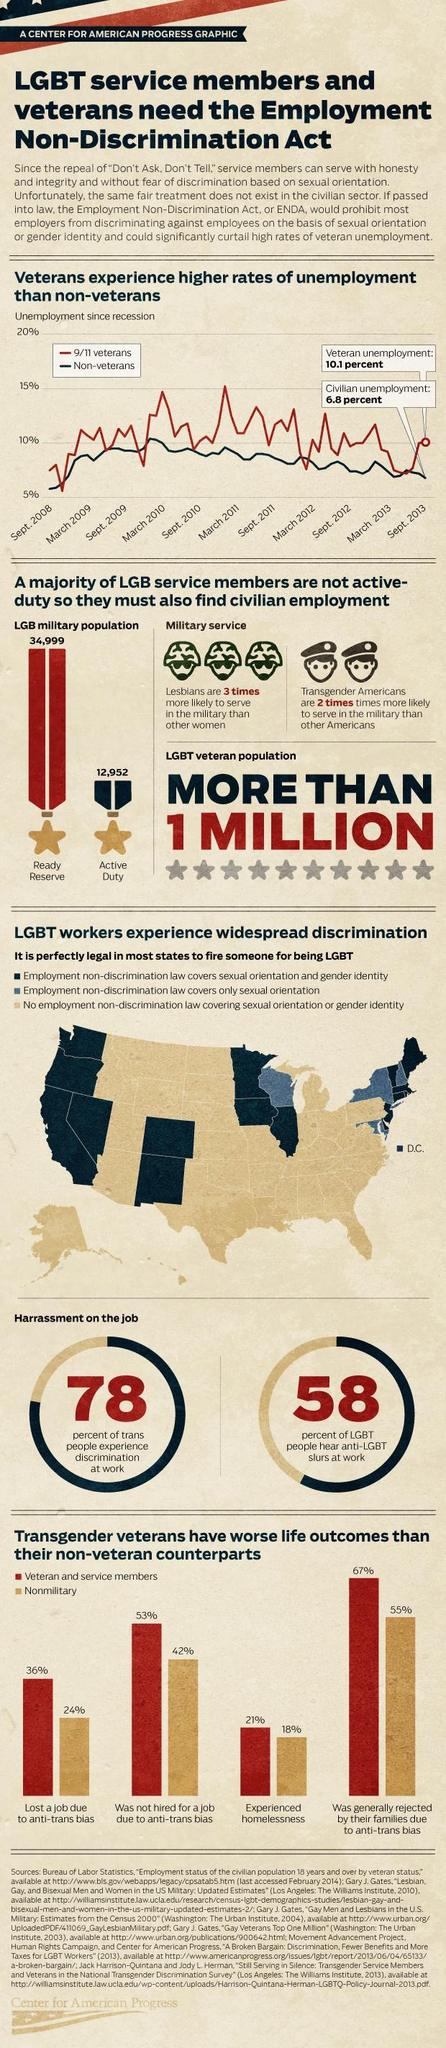What percent of veteran and service members experienced homelessness?
Answer the question with a short phrase. 21% What percent of nonmilitary lost a job due to anti-trans bias? 24% 55% of which group was rejected by their families due to anti-trans bias? Nonmilitary Who had the highest rate of unemployment as of Sept. 2013? 9/11 veterans When did the unemployment rate of 9/11 veterans reach peak? March 2011 How many LGB military personnel are on active duty? 12,952 